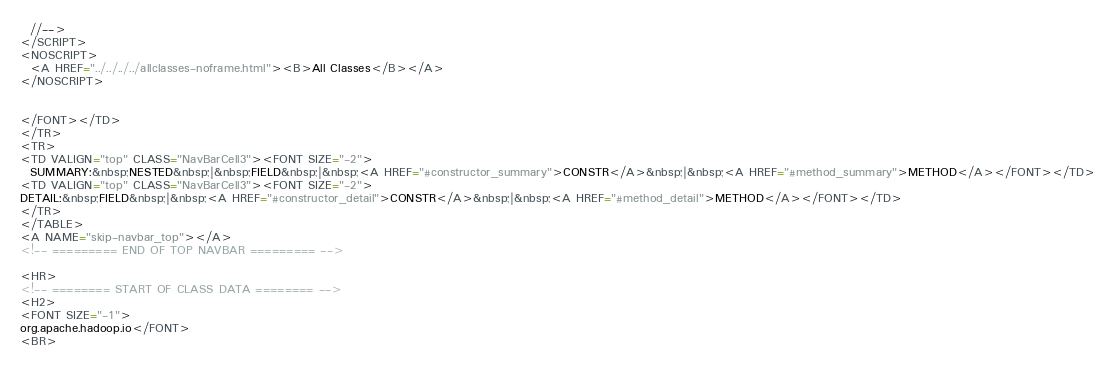Convert code to text. <code><loc_0><loc_0><loc_500><loc_500><_HTML_>  //-->
</SCRIPT>
<NOSCRIPT>
  <A HREF="../../../../allclasses-noframe.html"><B>All Classes</B></A>
</NOSCRIPT>


</FONT></TD>
</TR>
<TR>
<TD VALIGN="top" CLASS="NavBarCell3"><FONT SIZE="-2">
  SUMMARY:&nbsp;NESTED&nbsp;|&nbsp;FIELD&nbsp;|&nbsp;<A HREF="#constructor_summary">CONSTR</A>&nbsp;|&nbsp;<A HREF="#method_summary">METHOD</A></FONT></TD>
<TD VALIGN="top" CLASS="NavBarCell3"><FONT SIZE="-2">
DETAIL:&nbsp;FIELD&nbsp;|&nbsp;<A HREF="#constructor_detail">CONSTR</A>&nbsp;|&nbsp;<A HREF="#method_detail">METHOD</A></FONT></TD>
</TR>
</TABLE>
<A NAME="skip-navbar_top"></A>
<!-- ========= END OF TOP NAVBAR ========= -->

<HR>
<!-- ======== START OF CLASS DATA ======== -->
<H2>
<FONT SIZE="-1">
org.apache.hadoop.io</FONT>
<BR></code> 